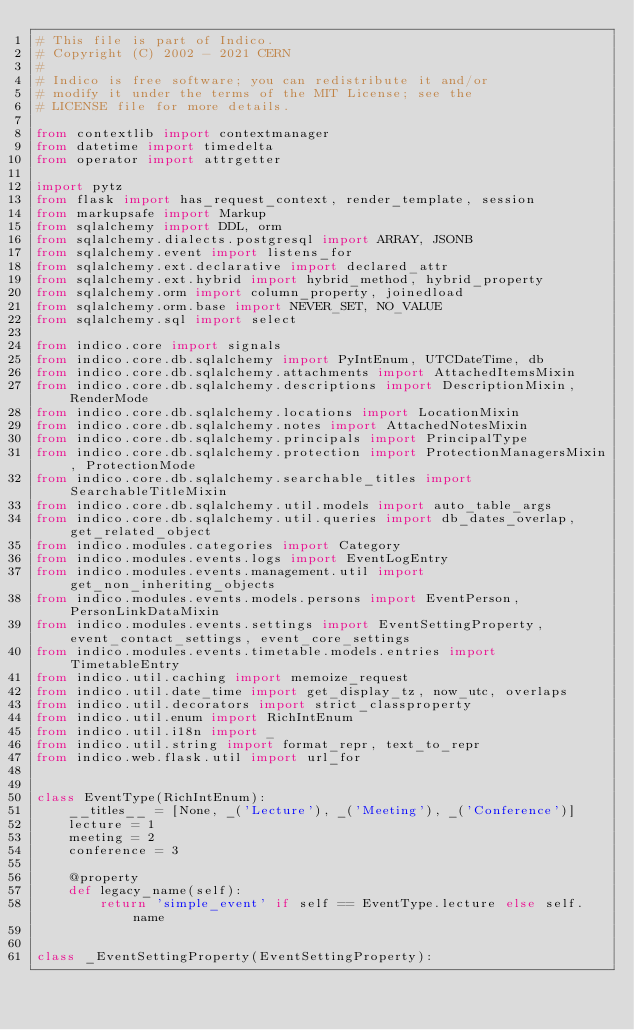<code> <loc_0><loc_0><loc_500><loc_500><_Python_># This file is part of Indico.
# Copyright (C) 2002 - 2021 CERN
#
# Indico is free software; you can redistribute it and/or
# modify it under the terms of the MIT License; see the
# LICENSE file for more details.

from contextlib import contextmanager
from datetime import timedelta
from operator import attrgetter

import pytz
from flask import has_request_context, render_template, session
from markupsafe import Markup
from sqlalchemy import DDL, orm
from sqlalchemy.dialects.postgresql import ARRAY, JSONB
from sqlalchemy.event import listens_for
from sqlalchemy.ext.declarative import declared_attr
from sqlalchemy.ext.hybrid import hybrid_method, hybrid_property
from sqlalchemy.orm import column_property, joinedload
from sqlalchemy.orm.base import NEVER_SET, NO_VALUE
from sqlalchemy.sql import select

from indico.core import signals
from indico.core.db.sqlalchemy import PyIntEnum, UTCDateTime, db
from indico.core.db.sqlalchemy.attachments import AttachedItemsMixin
from indico.core.db.sqlalchemy.descriptions import DescriptionMixin, RenderMode
from indico.core.db.sqlalchemy.locations import LocationMixin
from indico.core.db.sqlalchemy.notes import AttachedNotesMixin
from indico.core.db.sqlalchemy.principals import PrincipalType
from indico.core.db.sqlalchemy.protection import ProtectionManagersMixin, ProtectionMode
from indico.core.db.sqlalchemy.searchable_titles import SearchableTitleMixin
from indico.core.db.sqlalchemy.util.models import auto_table_args
from indico.core.db.sqlalchemy.util.queries import db_dates_overlap, get_related_object
from indico.modules.categories import Category
from indico.modules.events.logs import EventLogEntry
from indico.modules.events.management.util import get_non_inheriting_objects
from indico.modules.events.models.persons import EventPerson, PersonLinkDataMixin
from indico.modules.events.settings import EventSettingProperty, event_contact_settings, event_core_settings
from indico.modules.events.timetable.models.entries import TimetableEntry
from indico.util.caching import memoize_request
from indico.util.date_time import get_display_tz, now_utc, overlaps
from indico.util.decorators import strict_classproperty
from indico.util.enum import RichIntEnum
from indico.util.i18n import _
from indico.util.string import format_repr, text_to_repr
from indico.web.flask.util import url_for


class EventType(RichIntEnum):
    __titles__ = [None, _('Lecture'), _('Meeting'), _('Conference')]
    lecture = 1
    meeting = 2
    conference = 3

    @property
    def legacy_name(self):
        return 'simple_event' if self == EventType.lecture else self.name


class _EventSettingProperty(EventSettingProperty):</code> 